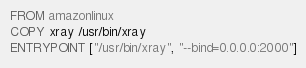Convert code to text. <code><loc_0><loc_0><loc_500><loc_500><_Dockerfile_>FROM amazonlinux
COPY xray /usr/bin/xray
ENTRYPOINT ["/usr/bin/xray", "--bind=0.0.0.0:2000"]</code> 